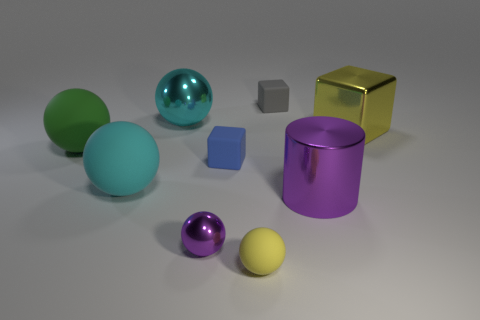Subtract all large balls. How many balls are left? 2 Add 1 small purple cubes. How many objects exist? 10 Subtract all yellow cubes. How many cubes are left? 2 Subtract all spheres. How many objects are left? 4 Subtract 2 balls. How many balls are left? 3 Add 4 big purple metallic cylinders. How many big purple metallic cylinders exist? 5 Subtract 0 cyan blocks. How many objects are left? 9 Subtract all blue blocks. Subtract all green balls. How many blocks are left? 2 Subtract all green blocks. How many yellow cylinders are left? 0 Subtract all gray things. Subtract all small rubber balls. How many objects are left? 7 